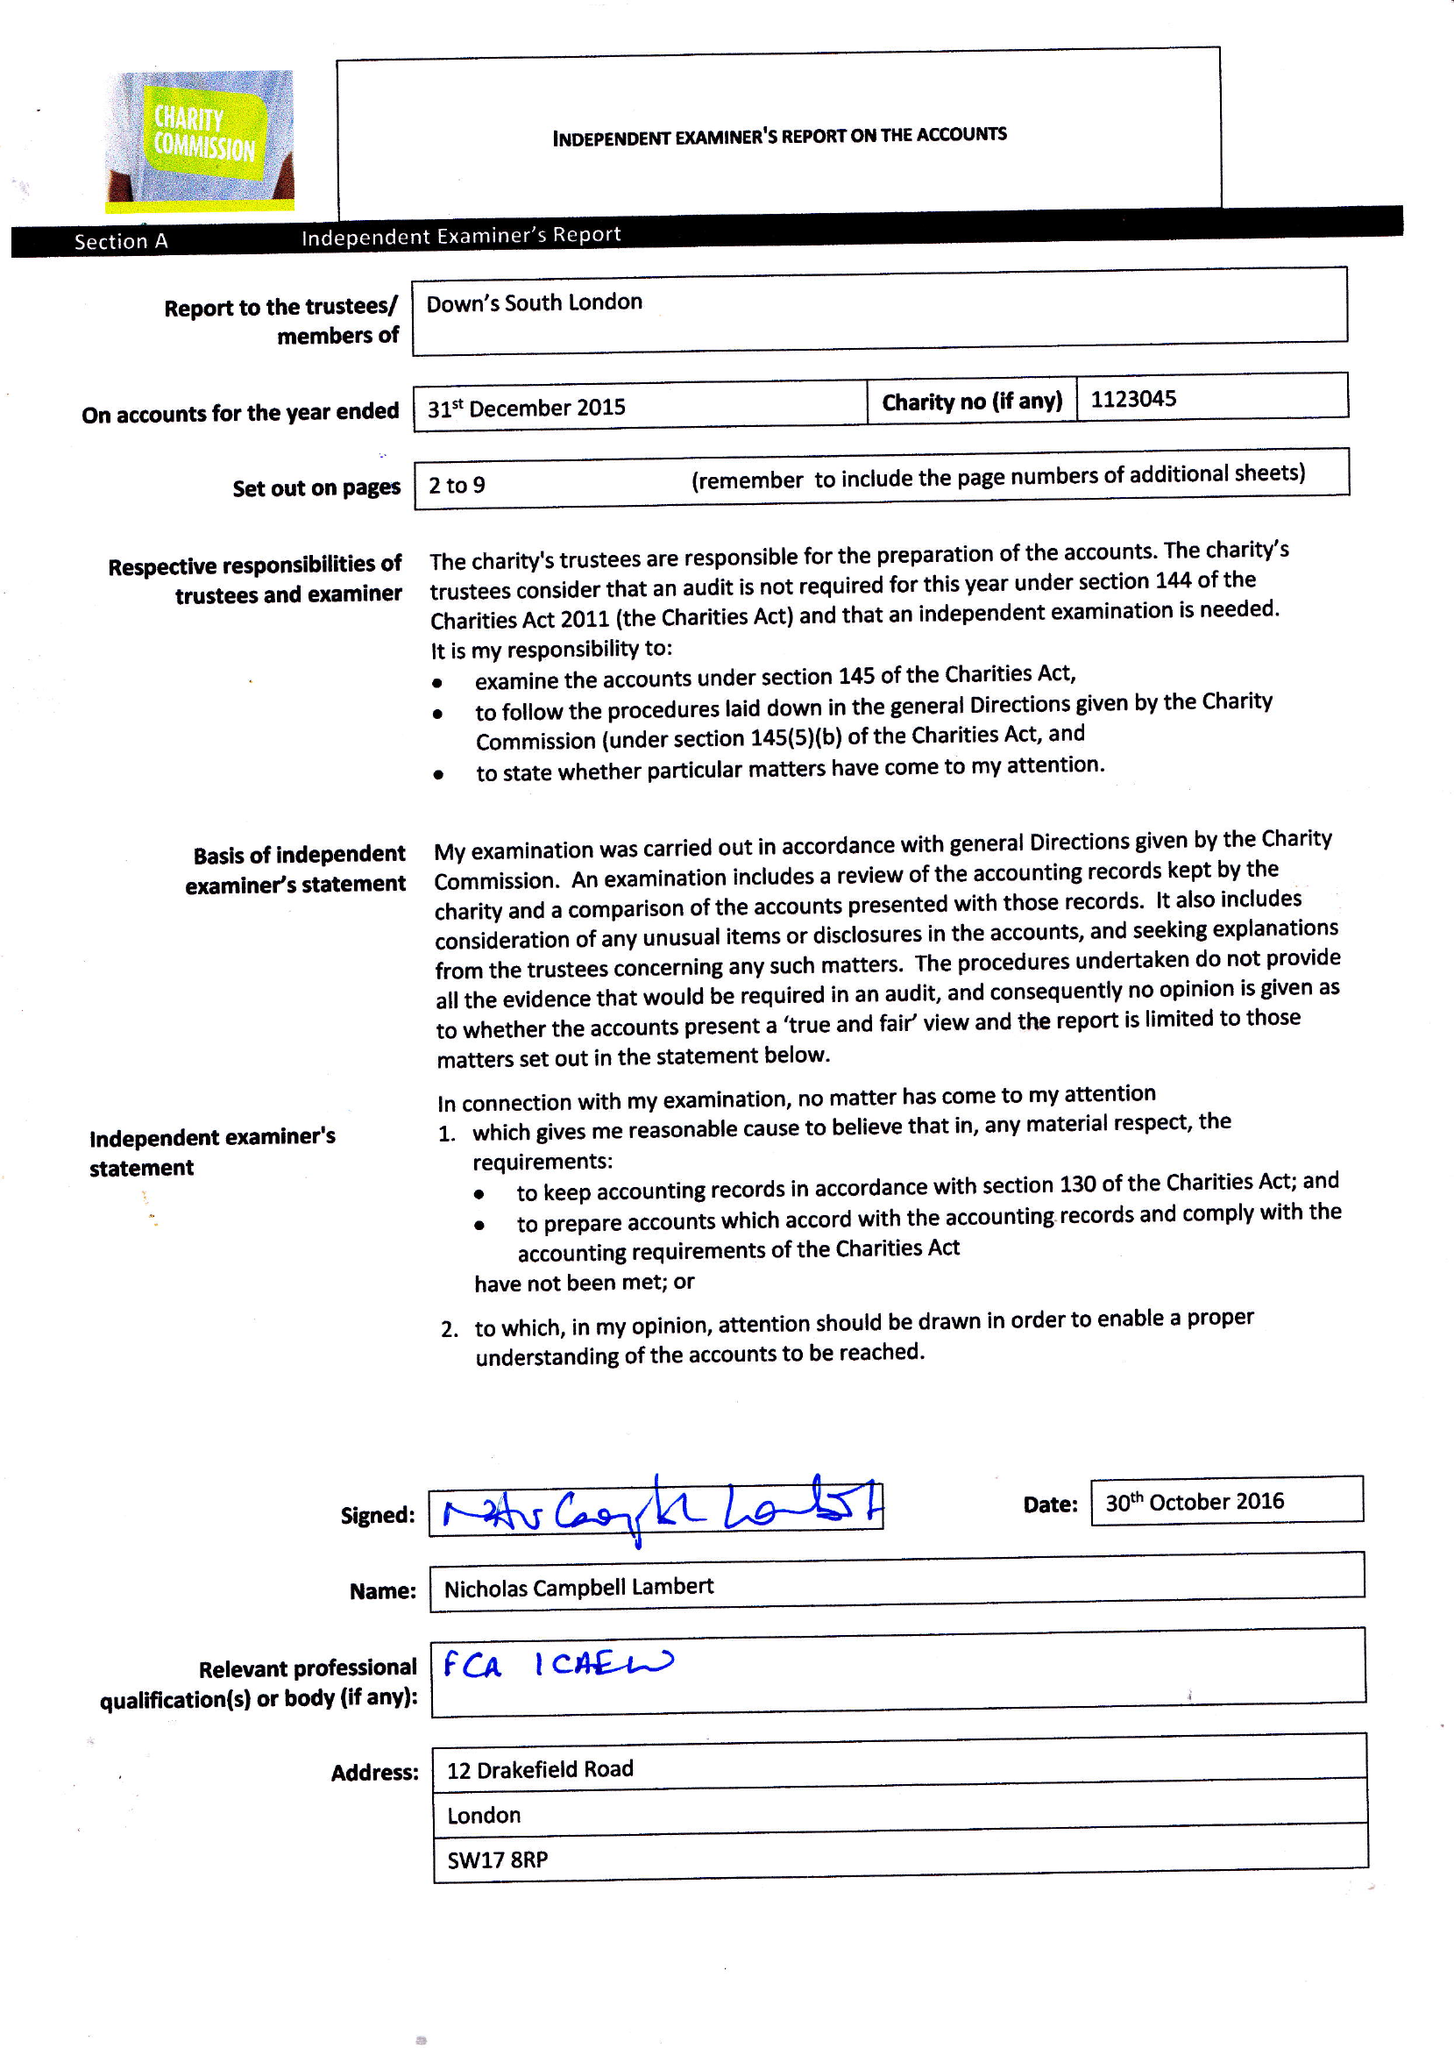What is the value for the address__postcode?
Answer the question using a single word or phrase. SE15 5AW 